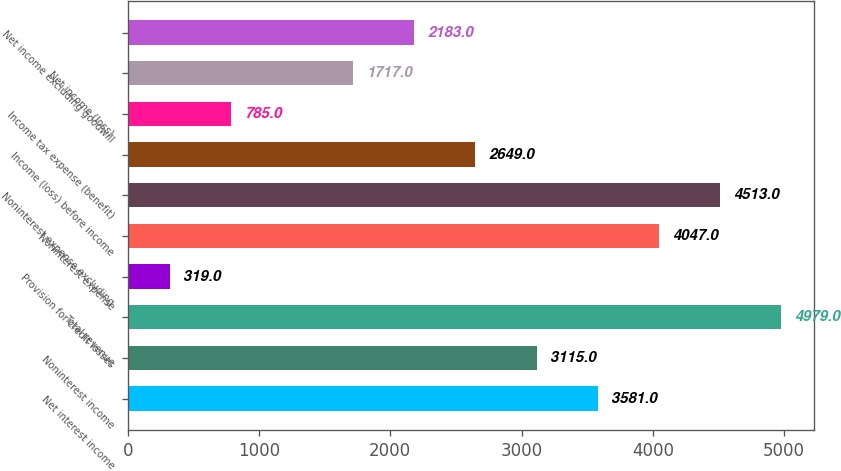Convert chart to OTSL. <chart><loc_0><loc_0><loc_500><loc_500><bar_chart><fcel>Net interest income<fcel>Noninterest income<fcel>Total revenue<fcel>Provision for credit losses<fcel>Noninterest expense<fcel>Noninterest expense excluding<fcel>Income (loss) before income<fcel>Income tax expense (benefit)<fcel>Net income (loss)<fcel>Net income excluding goodwill<nl><fcel>3581<fcel>3115<fcel>4979<fcel>319<fcel>4047<fcel>4513<fcel>2649<fcel>785<fcel>1717<fcel>2183<nl></chart> 